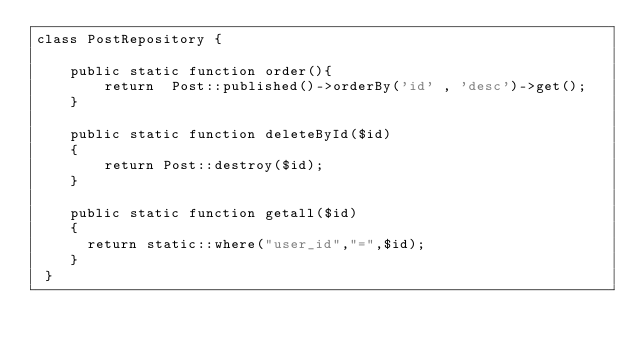Convert code to text. <code><loc_0><loc_0><loc_500><loc_500><_PHP_>class PostRepository {

	public static function order(){
		return  Post::published()->orderBy('id' , 'desc')->get();
	}

	public static function deleteById($id)
    {
        return Post::destroy($id);
    }

    public static function getall($id)
    {
      return static::where("user_id","=",$id); 
    }
 }</code> 